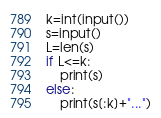Convert code to text. <code><loc_0><loc_0><loc_500><loc_500><_Python_>k=int(input())
s=input()
L=len(s)
if L<=k:
    print(s)
else:
    print(s[:k]+"...")</code> 